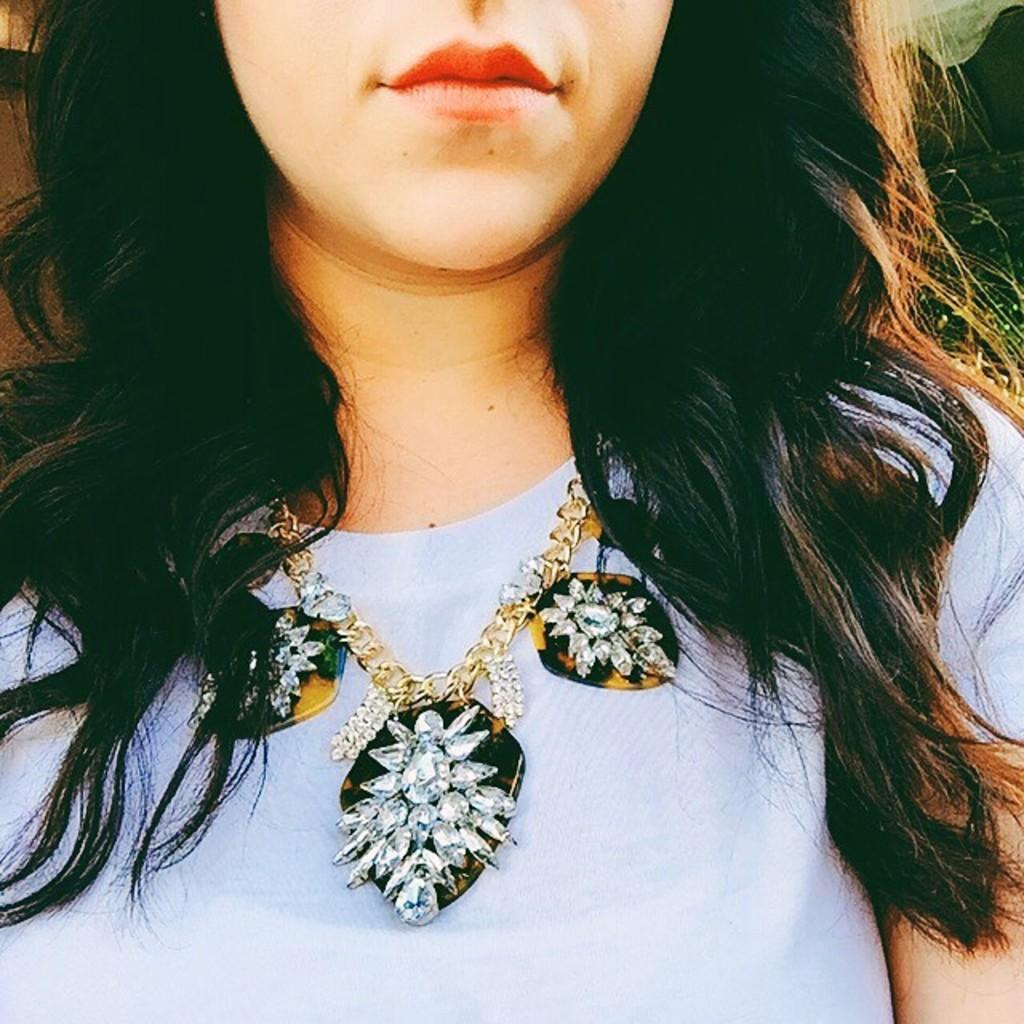Who is present in the image? There is a woman in the image. What is the woman wearing in the image? The woman is wearing a necklace. What type of dock can be seen in the image? There is no dock present in the image; it only features a woman wearing a necklace. 